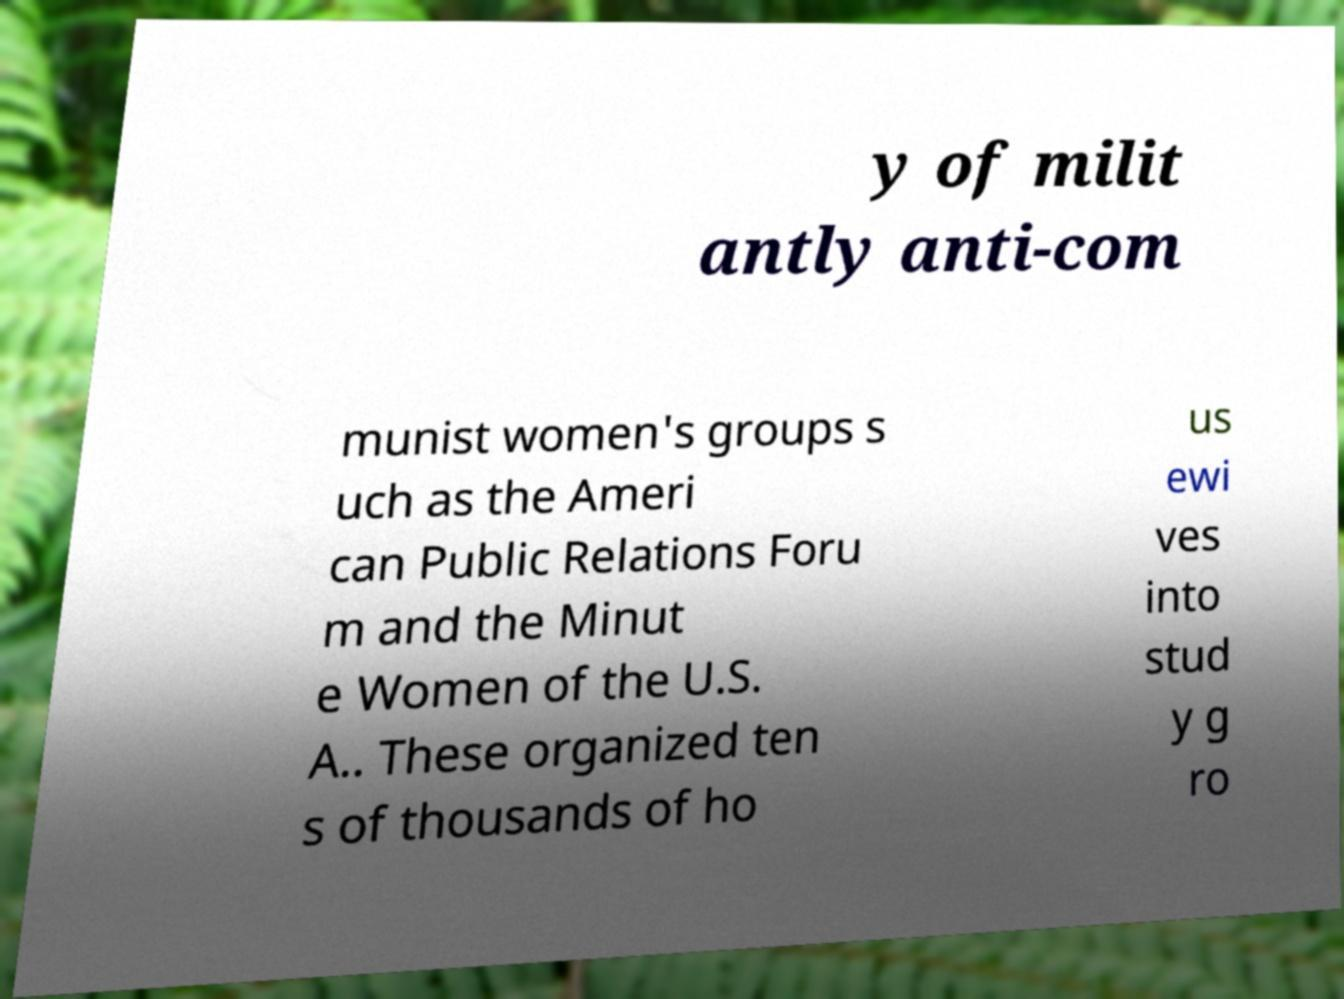Please read and relay the text visible in this image. What does it say? y of milit antly anti-com munist women's groups s uch as the Ameri can Public Relations Foru m and the Minut e Women of the U.S. A.. These organized ten s of thousands of ho us ewi ves into stud y g ro 